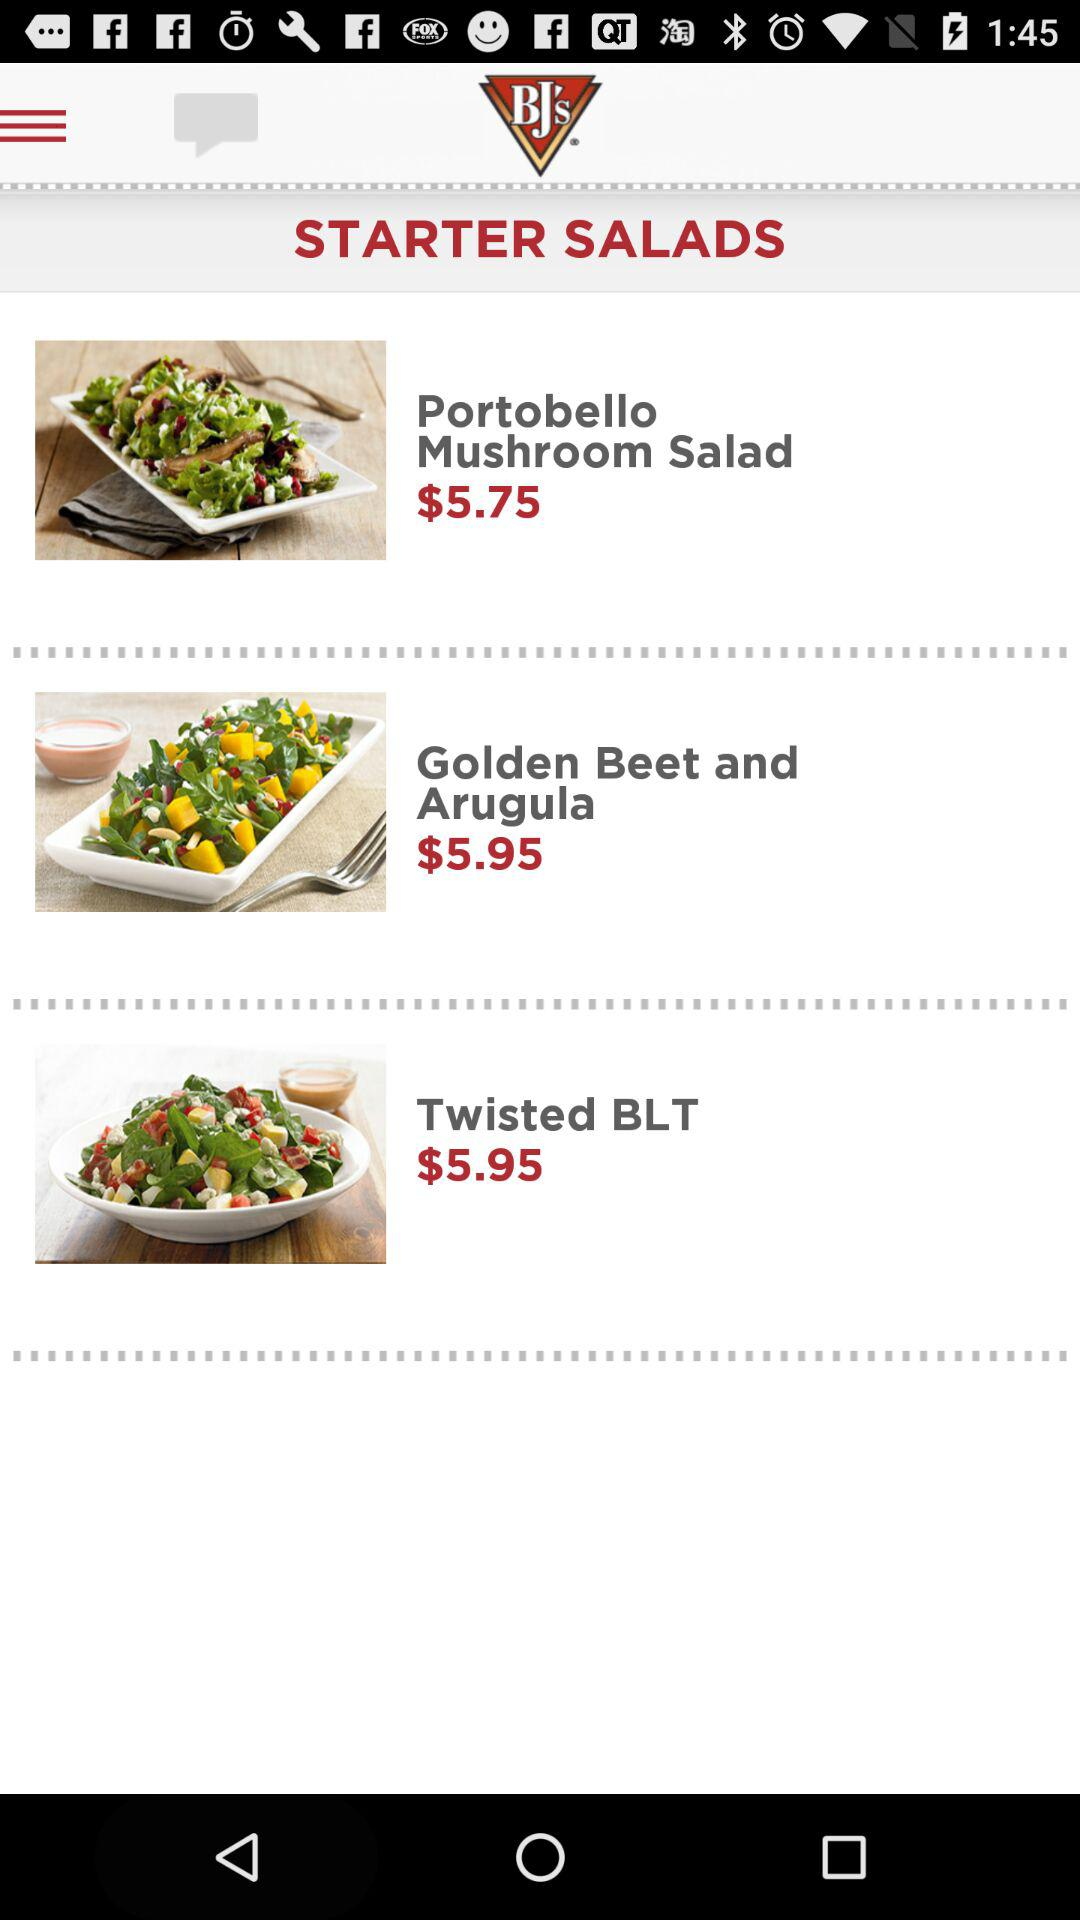What is the price of "Portobello Mushroom Salad"? The price of "Portobello Mushroom Salad" is $5.75. 